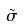<formula> <loc_0><loc_0><loc_500><loc_500>\tilde { \sigma }</formula> 